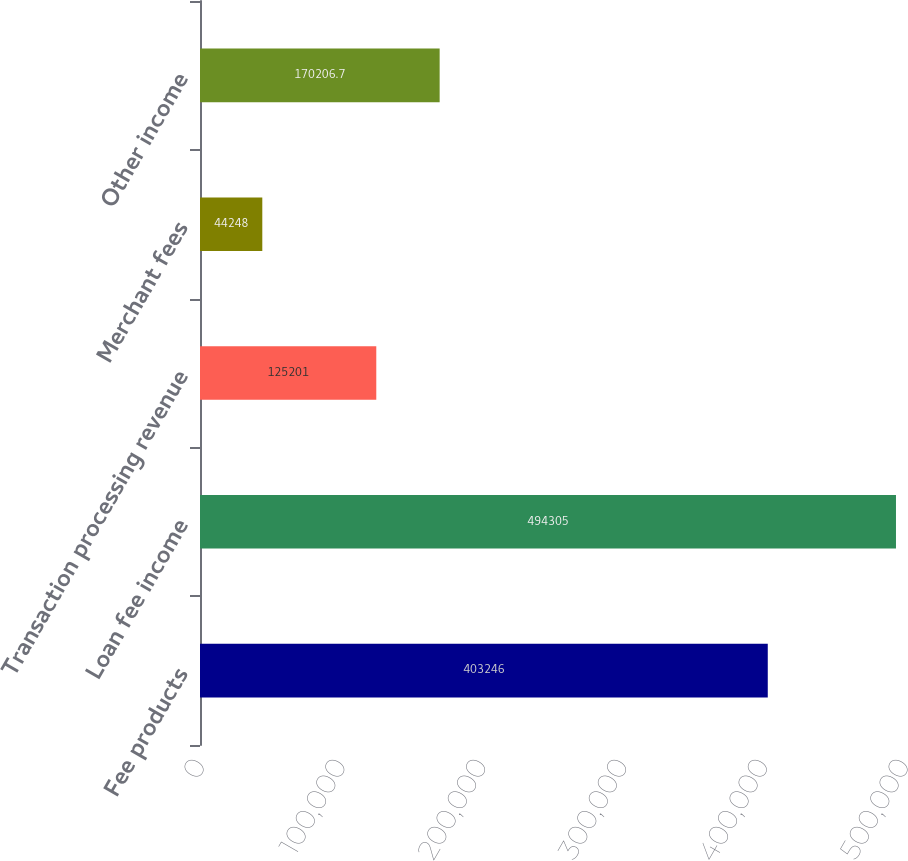Convert chart. <chart><loc_0><loc_0><loc_500><loc_500><bar_chart><fcel>Fee products<fcel>Loan fee income<fcel>Transaction processing revenue<fcel>Merchant fees<fcel>Other income<nl><fcel>403246<fcel>494305<fcel>125201<fcel>44248<fcel>170207<nl></chart> 